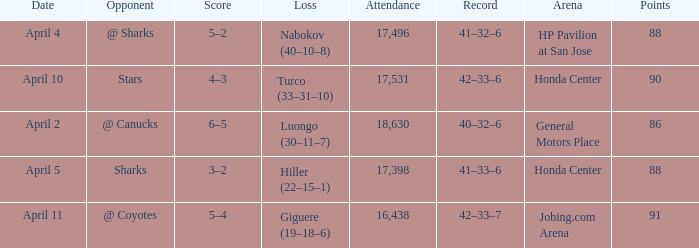How many Points have a Score of 3–2, and an Attendance larger than 17,398? None. 